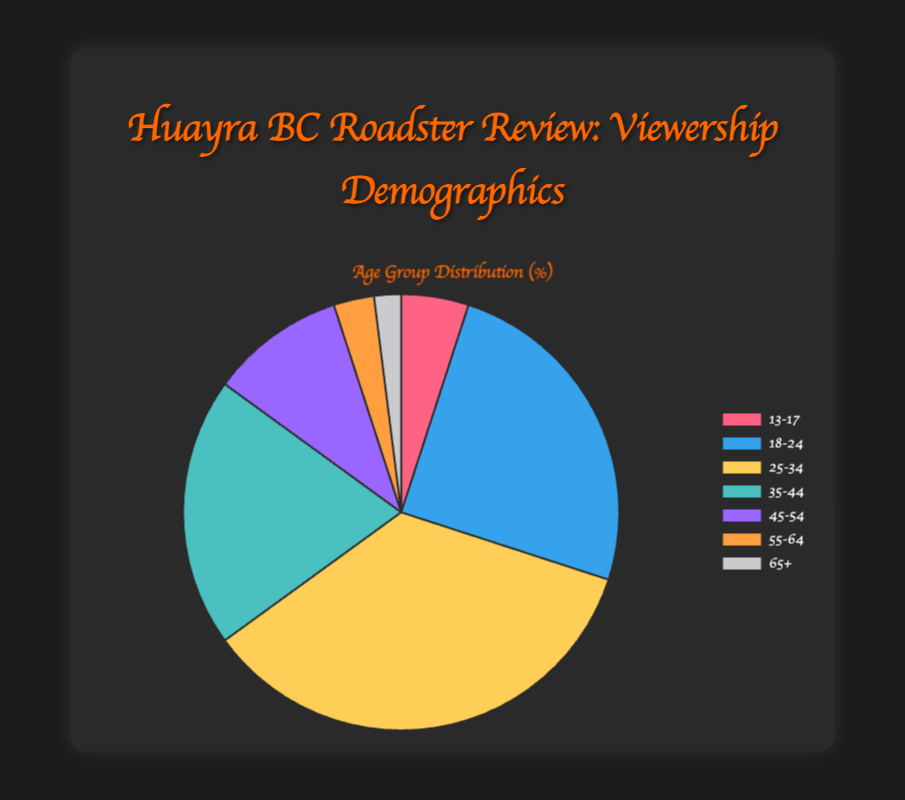what's the most represented age group in the viewership? The figure shows that the segment '25-34' has the largest portion of the pie chart, indicating it is the most represented age group.
Answer: 25-34 which age group has the smallest representation in the viewership? The figure shows that the segment '65+' is the smallest portion of the pie chart, indicating it has the smallest representation.
Answer: 65+ Which two age groups together make up less than 10% of the viewership? The segments '55-64' and '65+' combined account for 3% + 2% = 5%, which is less than 10%.
Answer: 55-64 and 65+ How much more percentage does the '25-34' age group represent compared to the '45-54' age group? The '25-34' age group represents 35%, while the '45-54' age group represents 10%. The difference is 35% - 10% = 25%.
Answer: 25% What is the combined percentage representation of the '18-24' and '35-44' age groups? Add the representations of '18-24' (25%) and '35-44' (20%). The combined representation is 25% + 20% = 45%.
Answer: 45% Which color represents the '18-24' age group in the pie chart? The '18-24' age group is visually represented by the blue segment in the pie chart.
Answer: Blue Compare the combined representation of '13-17' and '55-64'. Is it greater, less than, or equal to the '35-44' representation? The combined representation of '13-17' (5%) and '55-64' (3%) is 5% + 3% = 8%, which is less than the '35-44' representation of 20%.
Answer: less than What proportion of the viewership is younger than 25 years old? The segments younger than 25 years old are '13-17' (5%) and '18-24' (25%). The combined proportion is 5% + 25% = 30%.
Answer: 30% What is the difference in percentage between the '13-17' age group and the '55-64' age group? The '13-17' age group is 5%, and the '55-64' age group is 3%. The difference is 5% - 3% = 2%.
Answer: 2% Which two age groups appear to have a similar percentage representation? The segments '35-44' (20%) and '18-24' (25%) appear to have similar representations, although '18-24' is slightly higher, they are visually closer compared to others
Answer: 35-44 and 18-24 